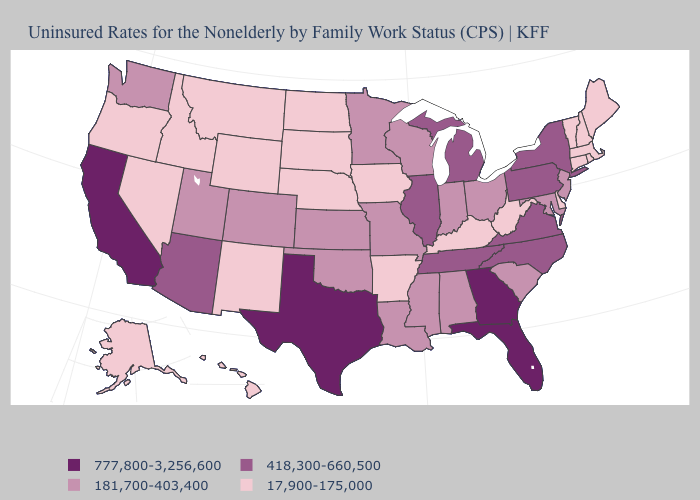Which states have the lowest value in the USA?
Short answer required. Alaska, Arkansas, Connecticut, Delaware, Hawaii, Idaho, Iowa, Kentucky, Maine, Massachusetts, Montana, Nebraska, Nevada, New Hampshire, New Mexico, North Dakota, Oregon, Rhode Island, South Dakota, Vermont, West Virginia, Wyoming. Name the states that have a value in the range 17,900-175,000?
Quick response, please. Alaska, Arkansas, Connecticut, Delaware, Hawaii, Idaho, Iowa, Kentucky, Maine, Massachusetts, Montana, Nebraska, Nevada, New Hampshire, New Mexico, North Dakota, Oregon, Rhode Island, South Dakota, Vermont, West Virginia, Wyoming. Name the states that have a value in the range 181,700-403,400?
Be succinct. Alabama, Colorado, Indiana, Kansas, Louisiana, Maryland, Minnesota, Mississippi, Missouri, New Jersey, Ohio, Oklahoma, South Carolina, Utah, Washington, Wisconsin. What is the highest value in the MidWest ?
Write a very short answer. 418,300-660,500. Does the first symbol in the legend represent the smallest category?
Concise answer only. No. Does Missouri have the lowest value in the MidWest?
Concise answer only. No. Does the first symbol in the legend represent the smallest category?
Give a very brief answer. No. What is the lowest value in the Northeast?
Answer briefly. 17,900-175,000. Name the states that have a value in the range 181,700-403,400?
Give a very brief answer. Alabama, Colorado, Indiana, Kansas, Louisiana, Maryland, Minnesota, Mississippi, Missouri, New Jersey, Ohio, Oklahoma, South Carolina, Utah, Washington, Wisconsin. Name the states that have a value in the range 181,700-403,400?
Keep it brief. Alabama, Colorado, Indiana, Kansas, Louisiana, Maryland, Minnesota, Mississippi, Missouri, New Jersey, Ohio, Oklahoma, South Carolina, Utah, Washington, Wisconsin. What is the value of Maryland?
Give a very brief answer. 181,700-403,400. Name the states that have a value in the range 418,300-660,500?
Answer briefly. Arizona, Illinois, Michigan, New York, North Carolina, Pennsylvania, Tennessee, Virginia. Name the states that have a value in the range 17,900-175,000?
Answer briefly. Alaska, Arkansas, Connecticut, Delaware, Hawaii, Idaho, Iowa, Kentucky, Maine, Massachusetts, Montana, Nebraska, Nevada, New Hampshire, New Mexico, North Dakota, Oregon, Rhode Island, South Dakota, Vermont, West Virginia, Wyoming. Does the map have missing data?
Write a very short answer. No. Which states have the highest value in the USA?
Quick response, please. California, Florida, Georgia, Texas. 